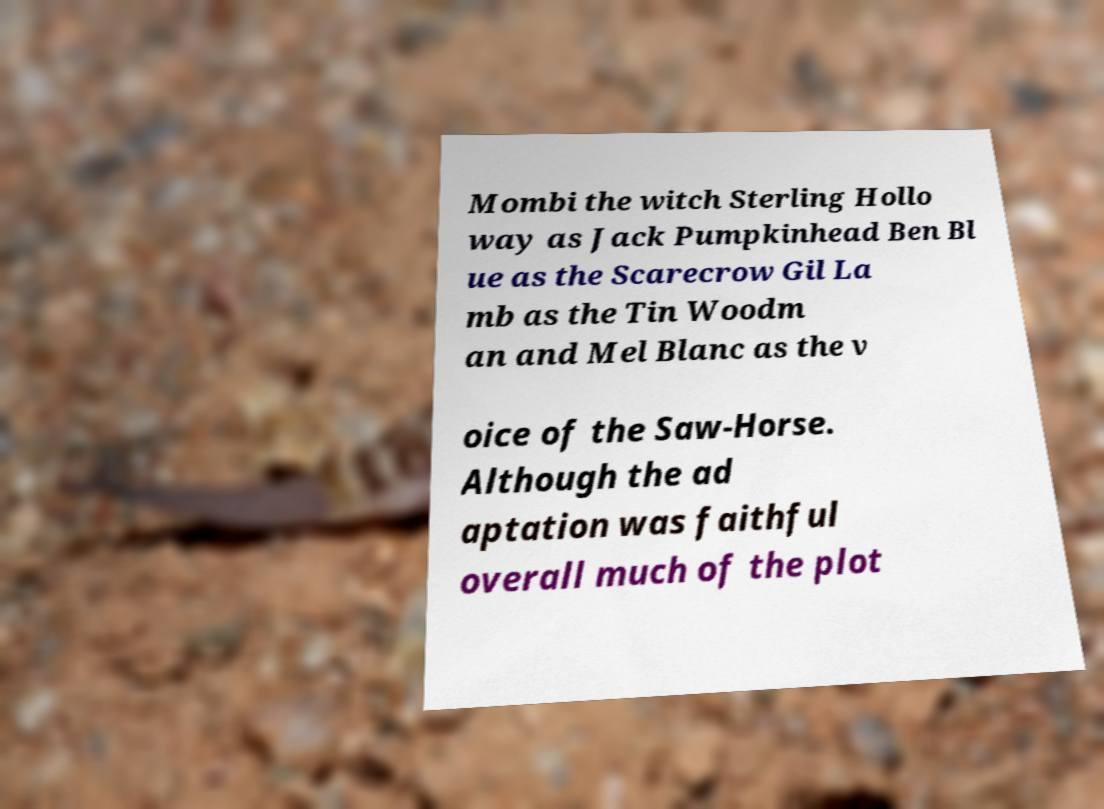For documentation purposes, I need the text within this image transcribed. Could you provide that? Mombi the witch Sterling Hollo way as Jack Pumpkinhead Ben Bl ue as the Scarecrow Gil La mb as the Tin Woodm an and Mel Blanc as the v oice of the Saw-Horse. Although the ad aptation was faithful overall much of the plot 